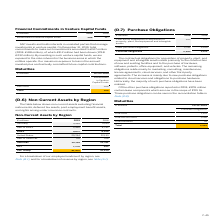According to Sap Ag's financial document, What information does the table show? non-current assets excluding financial instruments, deferred tax assets, post-employment benefit assets, and rights arising under insurance contracts.. The document states: "The table below shows non-current assets excluding financial instruments, deferred tax assets, post-employment benefit assets, and rights arising unde..." Also, What was the amount of non-current assets in APJ in 2019? According to the financial document, 1,276 (in millions). The relevant text states: "APJ 1,276 922..." Also, In which years were the Non-Current Assets by Region calculated? The document shows two values: 2019 and 2018. From the document: "€ millions 2019 2018 € millions 2019 2018..." Additionally, In which year was the amount in Rest of Americas larger? According to the financial document, 2019. The relevant text states: "€ millions 2019 2018..." Also, can you calculate: What was the change in the amount in Rest of Americas in 2019 from 2018? Based on the calculation: 411-258, the result is 153 (in millions). This is based on the information: "Rest of Americas 411 258 Rest of Americas 411 258..." The key data points involved are: 258, 411. Also, can you calculate: What was the percentage change in the amount in Rest of Americas in 2019 from 2018? To answer this question, I need to perform calculations using the financial data. The calculation is: (411-258)/258, which equals 59.3 (percentage). This is based on the information: "Rest of Americas 411 258 Rest of Americas 411 258..." The key data points involved are: 258, 411. 